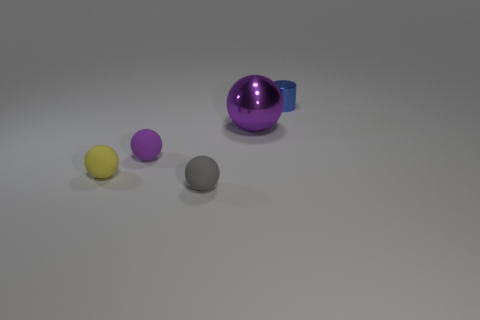Subtract all cyan balls. Subtract all green cylinders. How many balls are left? 4 Add 1 matte objects. How many objects exist? 6 Subtract all cylinders. How many objects are left? 4 Add 2 large metal balls. How many large metal balls are left? 3 Add 3 tiny yellow spheres. How many tiny yellow spheres exist? 4 Subtract 0 purple cylinders. How many objects are left? 5 Subtract all small red cubes. Subtract all small yellow rubber balls. How many objects are left? 4 